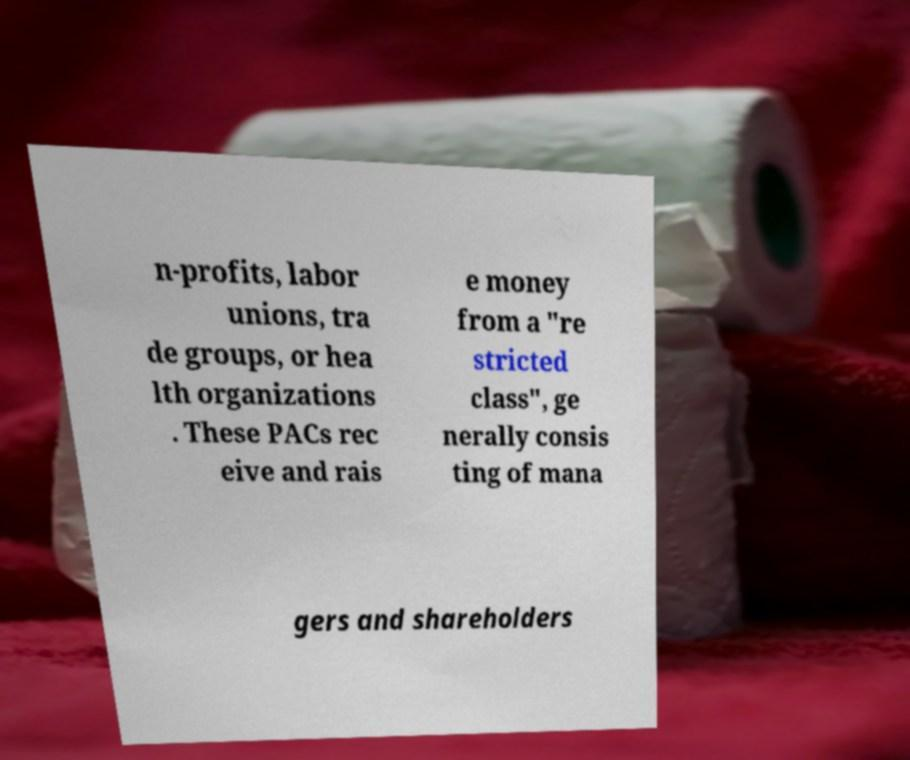I need the written content from this picture converted into text. Can you do that? n-profits, labor unions, tra de groups, or hea lth organizations . These PACs rec eive and rais e money from a "re stricted class", ge nerally consis ting of mana gers and shareholders 